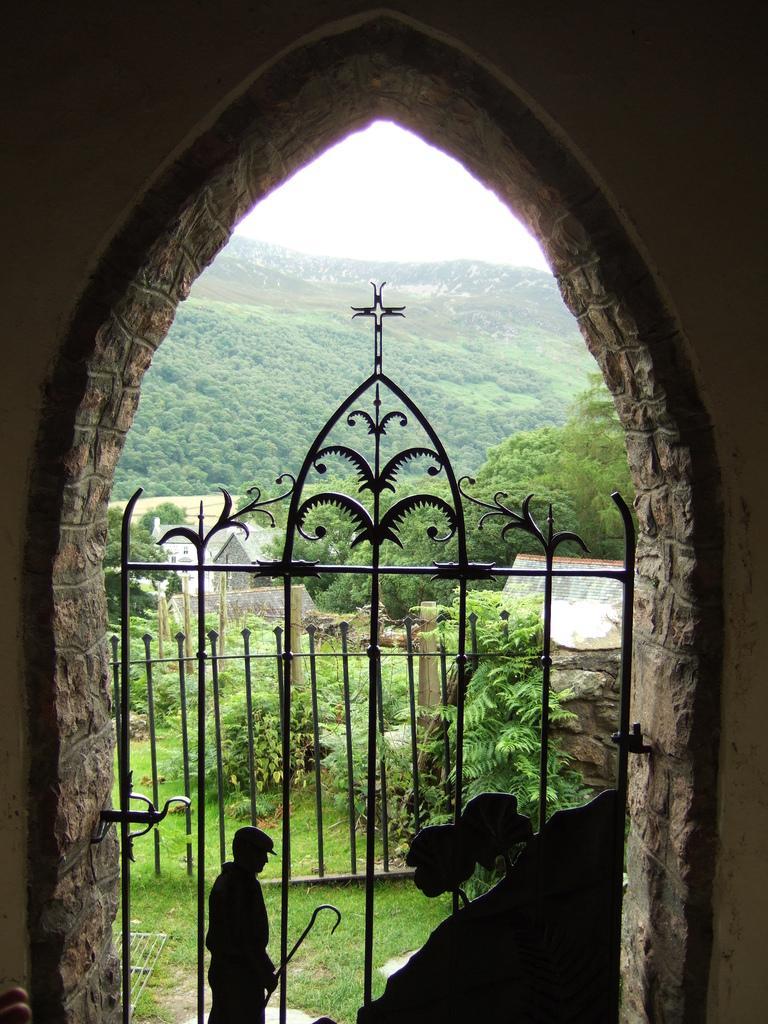Can you describe this image briefly? In this image we can see a metal gate under an arch. On the backside we can see a person standing on the ground holding a tool. We can also see some grass, plants, a group of trees, some houses, the hills and the sky which looks cloudy. 